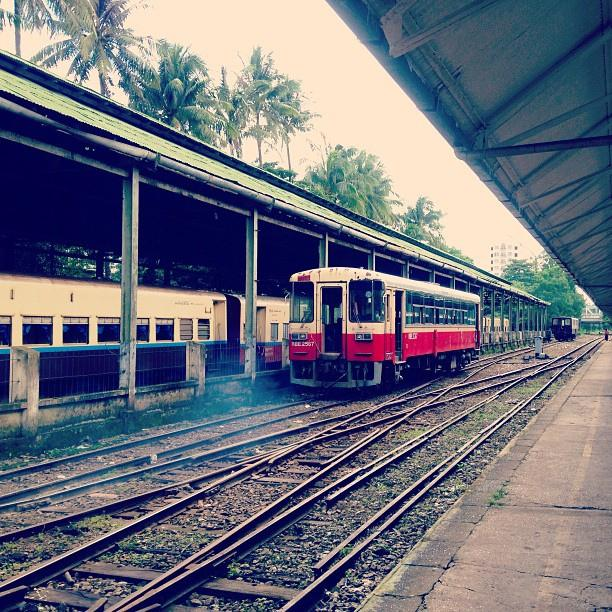Which word best describes this train station? Please explain your reasoning. decrepit. The station is mostly empty and does not seem to be in good shape. 